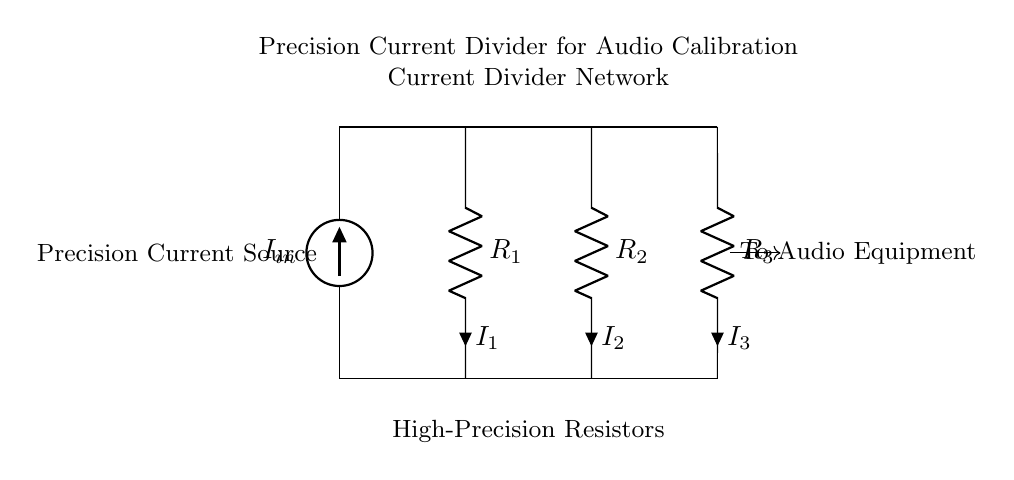What is the total number of resistors in the circuit? There are three resistors labeled as R1, R2, and R3, making it a total of three resistors in the current divider network.
Answer: three What is the function of the precision current source in this circuit? The precision current source provides a stable input current, which is essential for achieving accurate measurements and calibrations in high-end audio equipment.
Answer: provides stable input current Which resistor would see the highest current flow? The current is divided among R1, R2, and R3 based on their resistance values. The resistor with the lowest resistance would see the highest current flow, assuming R1, R2, and R3 have different values.
Answer: lowest resistance How does the current divider operate with respect to R1, R2, and R3? The current divider operates on the principle that the input current splits into fractions that are inversely proportional to the resistance values of R1, R2, and R3. Therefore, each resistor receives a portion of the total current based on its resistance.
Answer: current splits by resistance value What is the primary application of this circuit in audio equipment? This circuit is primarily used for calibrating high-end audio recording equipment by ensuring accurate current distribution and measuring capabilities within the audio signal path.
Answer: calibrating audio equipment What might happen if one of the resistors fails or is removed? If one of the resistors fails or is removed, it would disrupt the current division, potentially leading to an overload of the remaining resistors or erroneous calibration readings, which could damage the audio equipment.
Answer: disrupt current division How can the accuracy of this current divider circuit be improved? The accuracy can be improved by using higher precision resistors with tighter tolerances and lower temperature coefficients, thereby ensuring that the current division reflects true values and minimizes measurement errors.
Answer: use higher precision resistors 